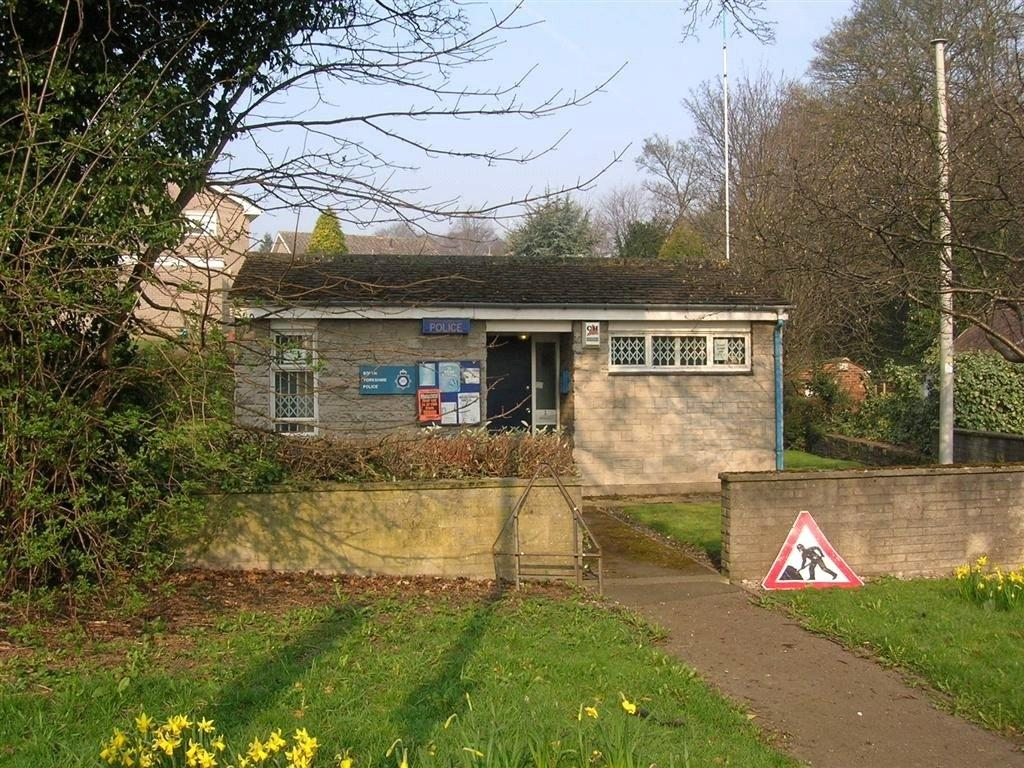What type of building is in the image? There is a police station in the image. What features can be seen on the police station? The police station has windows and boards on the walls. What can be seen in the background of the image? There are houses, trees, and grass visible in the background. What is the purpose of the signboard in the image? The signboard in the image likely provides information about the police station. What type of barrier surrounds the police station? There is a compound wall in the image. What other objects are present in the image? There are plants visible in the image. What type of furniture can be seen inside the police station in the image? There is no furniture visible inside the police station in the image. How many lizards are sitting on the compound wall in the image? There are no lizards present in the image. 